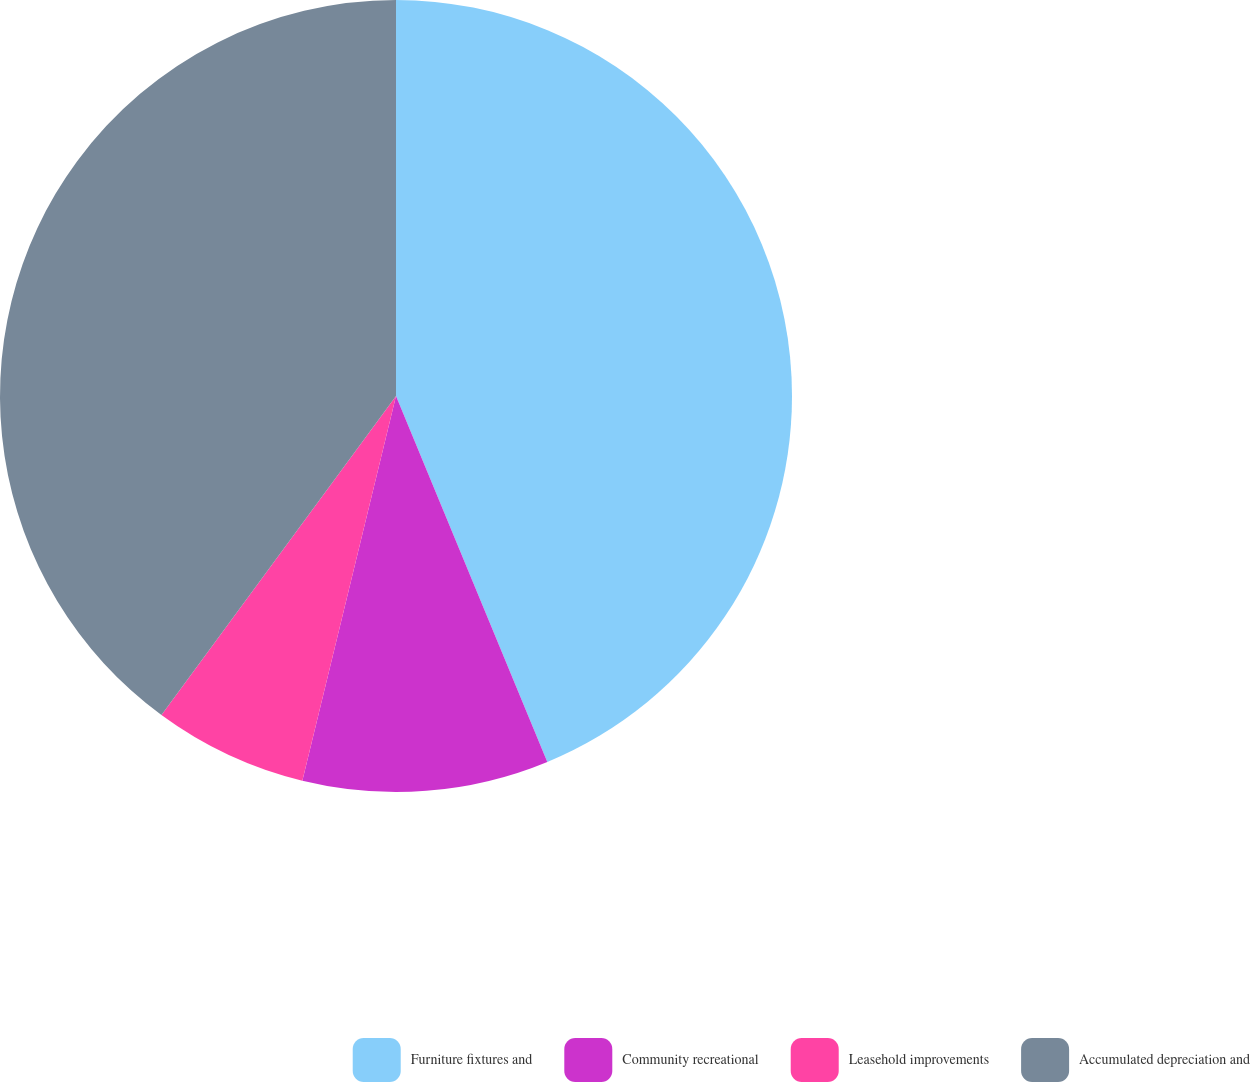Convert chart. <chart><loc_0><loc_0><loc_500><loc_500><pie_chart><fcel>Furniture fixtures and<fcel>Community recreational<fcel>Leasehold improvements<fcel>Accumulated depreciation and<nl><fcel>43.76%<fcel>10.04%<fcel>6.29%<fcel>39.91%<nl></chart> 